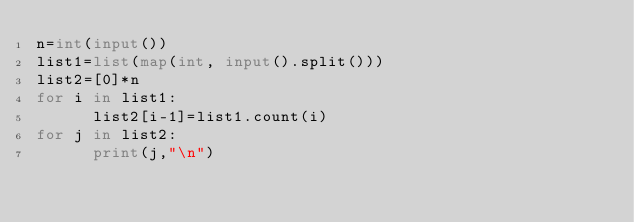Convert code to text. <code><loc_0><loc_0><loc_500><loc_500><_Python_>n=int(input())
list1=list(map(int, input().split()))
list2=[0]*n
for i in list1:
      list2[i-1]=list1.count(i)
for j in list2:
      print(j,"\n")</code> 